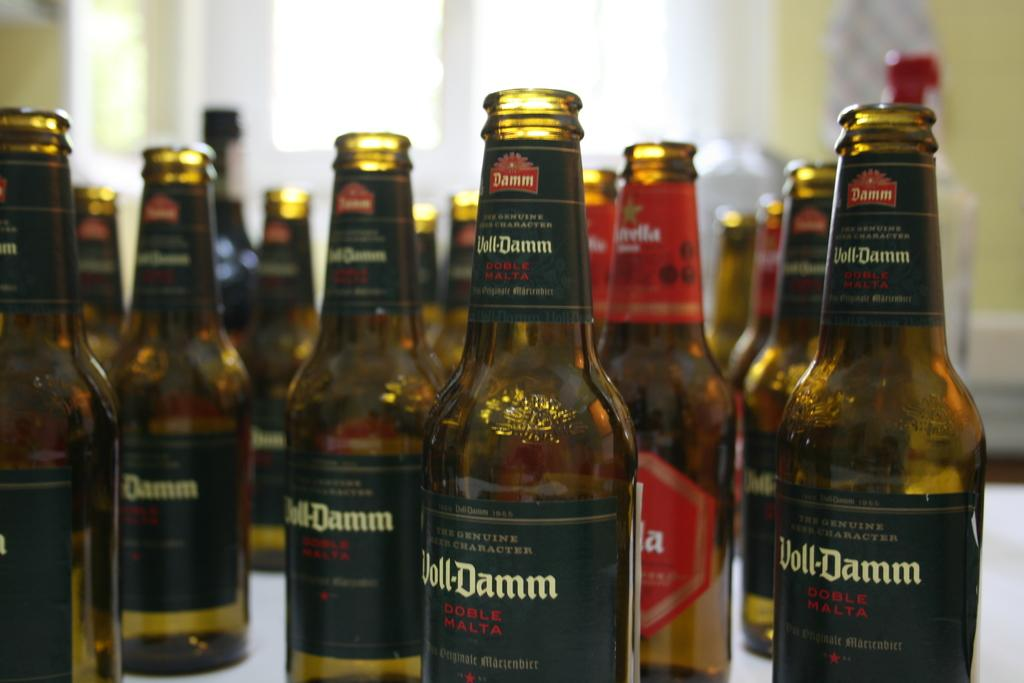<image>
Relay a brief, clear account of the picture shown. Numerous open bottles of Voll-Damm scattered on a table. 